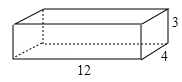How could this wooden box be utilized in a classroom setting? In a classroom environment, the wooden box from the image could serve multiple educational purposes. It could be a practical teaching aid in math for explaining concepts such as geometry, volume, and surface area. The box could also be used for storage, helping to organize classroom supplies. Furthermore, it could be part of a physics demonstration to illustrate principles related to weight, balance, and force, or in art class, to be decorated or incorporated into a larger project to encourage creativity and hands-on learning. 